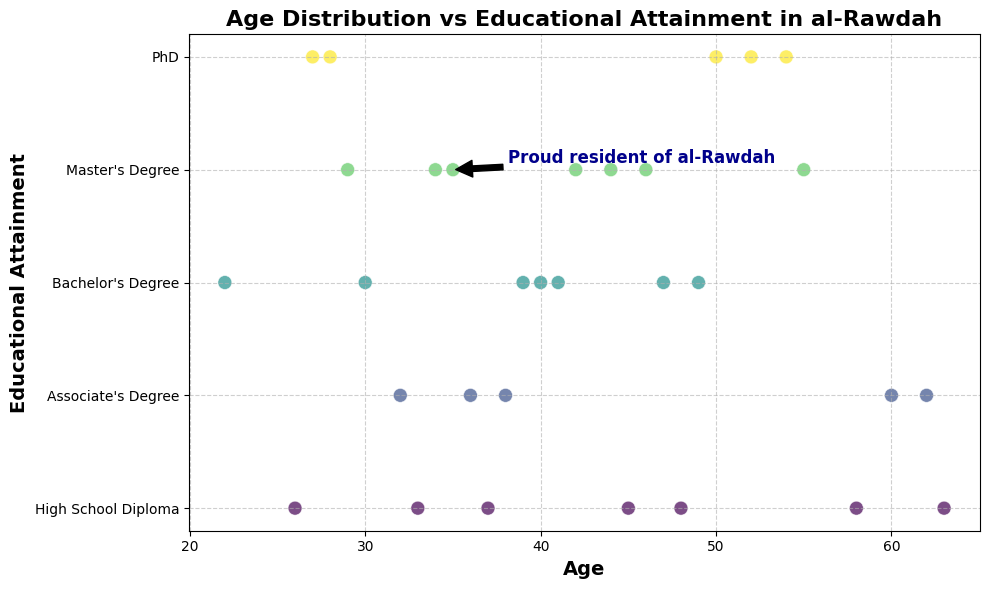What is the educational attainment level for the youngest resident in the plot? Locate the point corresponding to the youngest age on the x-axis, which is 22. The y-value for this point corresponds to a Bachelor's Degree.
Answer: Bachelor's Degree Which age group has the highest level of educational attainment? Identify the highest y-value on the plot. The highest y-value corresponds to the PhD level, visible at ages 28, 50, 54, 27, and 52.
Answer: Ages 27, 28, 50, 52, 54 How many residents have a Master's Degree, and what is their average age? Count the points corresponding to the Master's Degree level (y-value = 4), which are at ages 34, 35, 42, 44, 55, 46, and 29. Sum these ages (34 + 35 + 42 + 44 + 55 + 46 + 29 = 285) and divide by the count (7).
Answer: 7 residents, average age = 40.71 Compare the distribution of residents with a Bachelor's Degree versus an Associate's Degree. Which group has a wider age range? Find the ages for Bachelor's degree (22, 30, 47, 41, 49, 40, 39) and Associate's degree (38, 62, 36, 60, 32). Calculate the range for each: Bachelor's Degree (47-22 = 25), Associate's Degree (62-32 = 30).
Answer: Associate's Degree What is the median age of residents with a High School Diploma? Identify the ages corresponding to a High School Diploma (45, 63, 48, 33, 58, 37, 26) and sort them. The sorted ages are (26, 33, 37, 45, 48, 58, 63). The median age is the middle value (45).
Answer: 45 Is there a visual trend between age and educational attainment level? Observe the scatter plot to see if there is a notable pattern. Higher educational attainment levels appear to be distributed across a wide age range without a clear upward or downward trend.
Answer: No clear trend At what age is the annotated point in the figure, and what is the educational attainment at that age? The annotation points to a specific age. Trace the arrow annotation back to the x-axis, which marks age 35. The y-value for this age corresponds to a Master's Degree.
Answer: Age 35, Master's Degree How many residents are above 50 years old, and what is their most common educational attainment? Identify the points where the age is greater than 50 (55, 63, 50, 54, 58, 60, 52). Count the educational attainments: Master's Degree (1), High School Diploma (2), PhD (3), Associate's Degree (1). The most common attainment is PhD (3 residents).
Answer: 7 residents, PhD 